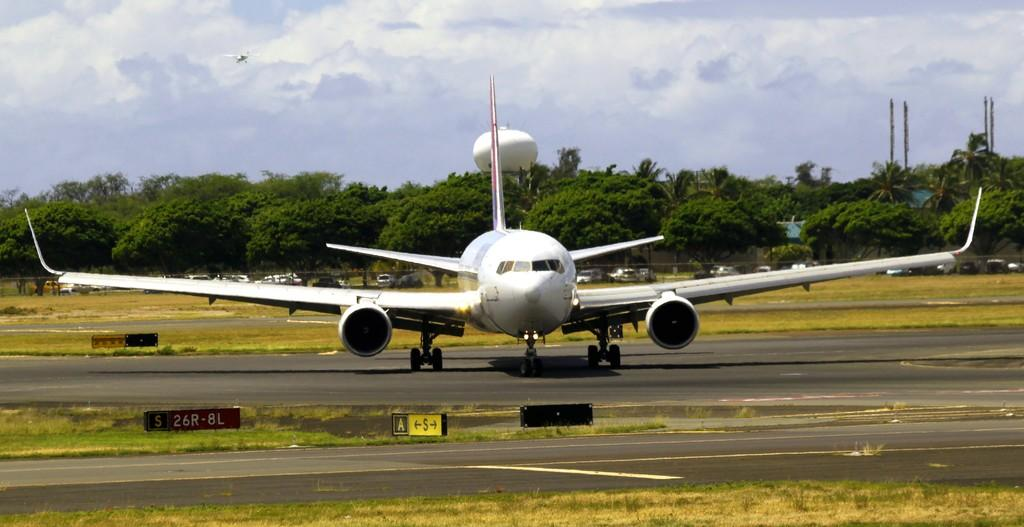Provide a one-sentence caption for the provided image. An airplane is sitting on a tarmack with a sign in front of it that says S 26R-8L. 